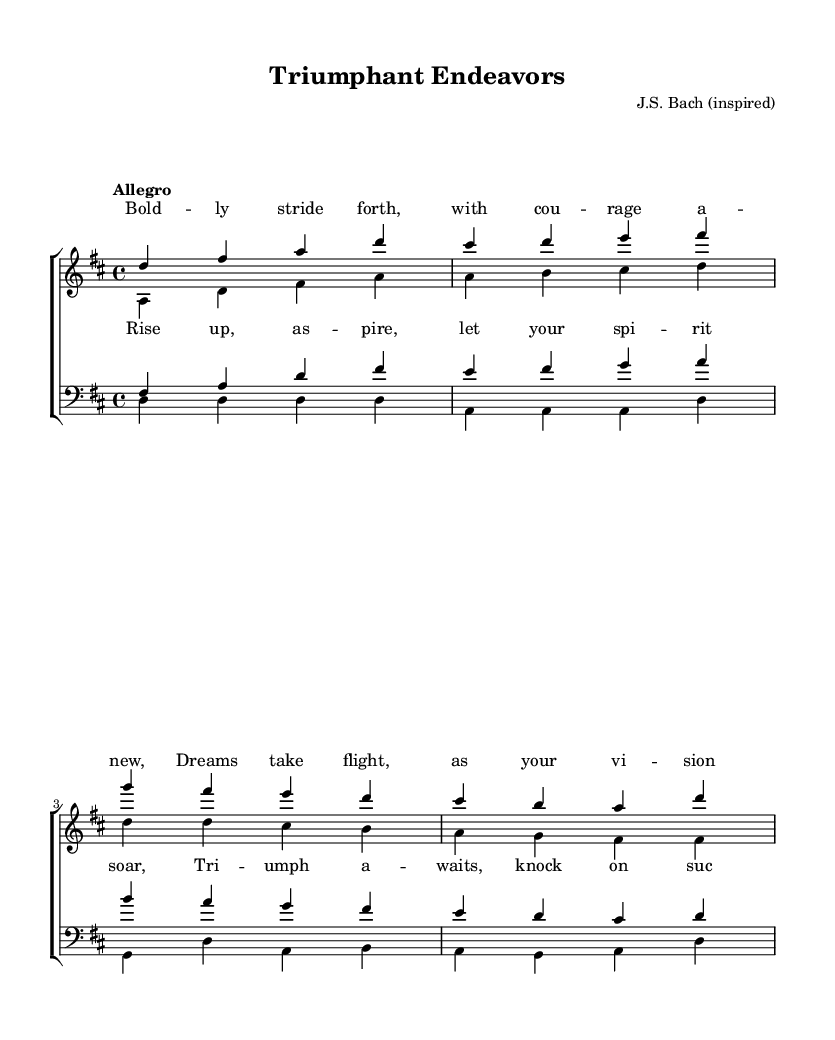What is the key signature of this music? The key signature is displayed at the beginning of the staff. It shows two sharps, indicating that the key is D major.
Answer: D major What is the time signature of this piece? The time signature appears at the start of the music, indicating a pattern of four beats in a measure, represented as 4/4.
Answer: 4/4 What is the tempo marking for this piece? The tempo marking, which dictates the speed of the music, is found above the staff and indicates "Allegro," suggesting a fast and lively pace.
Answer: Allegro How many vocal parts are there in this piece? The arrangement includes four distinct vocal parts: soprano, alto, tenor, and bass, as represented in the ChoirStaff.
Answer: Four What is the primary thematic message conveyed in the lyrics? The lyrics convey a motivating message about courage and aspiration, encouraging individuals to pursue their dreams and welcome success, as described in the provided verses and chorus.
Answer: Motivation Which musical style does this piece represent? The characteristics of the composition, such as complex harmonies and the choral format, suggest that this piece belongs to the Baroque era, which is defined by these stylistic features.
Answer: Baroque How does the musical structure support the uplifting theme? The use of major tonality, lively tempo, and a clear rise in melodic lines in both the verses and chorus create a sense of brightness and vigor, reinforcing the motivational lyrics aimed at inspiring confidence and action.
Answer: Uplifting structure 